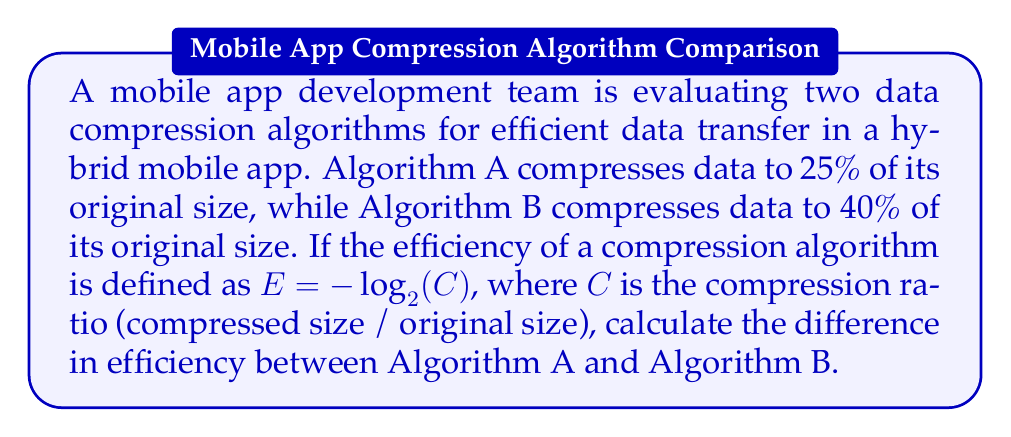Can you answer this question? Let's approach this step-by-step:

1. Define the efficiency formula:
   $E = -\log_2(C)$, where $C$ is the compression ratio

2. Calculate the compression ratio for Algorithm A:
   $C_A = 25\% = 0.25$

3. Calculate the compression ratio for Algorithm B:
   $C_B = 40\% = 0.40$

4. Calculate the efficiency of Algorithm A:
   $E_A = -\log_2(0.25)$
   $E_A = -\log_2(2^{-2})$
   $E_A = -(-2) = 2$

5. Calculate the efficiency of Algorithm B:
   $E_B = -\log_2(0.40)$
   $E_B = -\log_2(2^{-1.32193})$
   $E_B = -(-1.32193) \approx 1.32193$

6. Calculate the difference in efficiency:
   $\Delta E = E_A - E_B$
   $\Delta E = 2 - 1.32193$
   $\Delta E \approx 0.67807$

Therefore, the difference in efficiency between Algorithm A and Algorithm B is approximately 0.67807.
Answer: $0.67807$ 